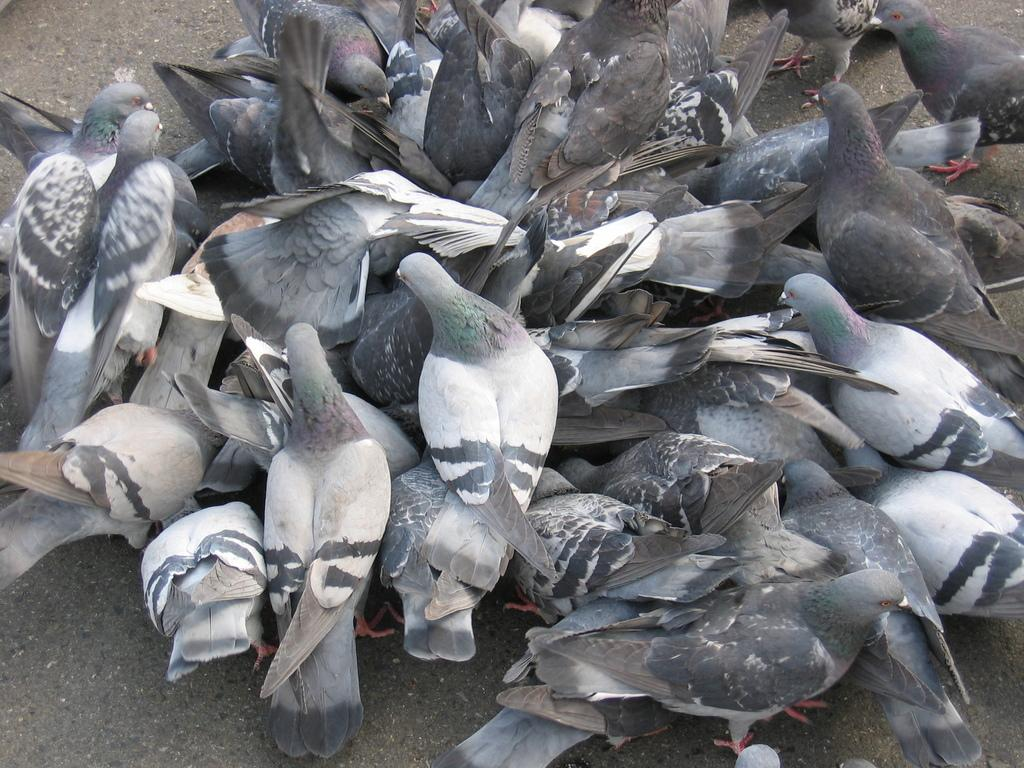What is the main subject of the image? There is a group of pigeons in the center of the image. Can you describe the location of the pigeons in the image? The pigeons are in the center of the image. What can be seen in the background of the image? There is ground visible in the background of the image. How many times do the pigeons sneeze in the image? There is no indication in the image that the pigeons are sneezing, so it cannot be determined from the picture. 